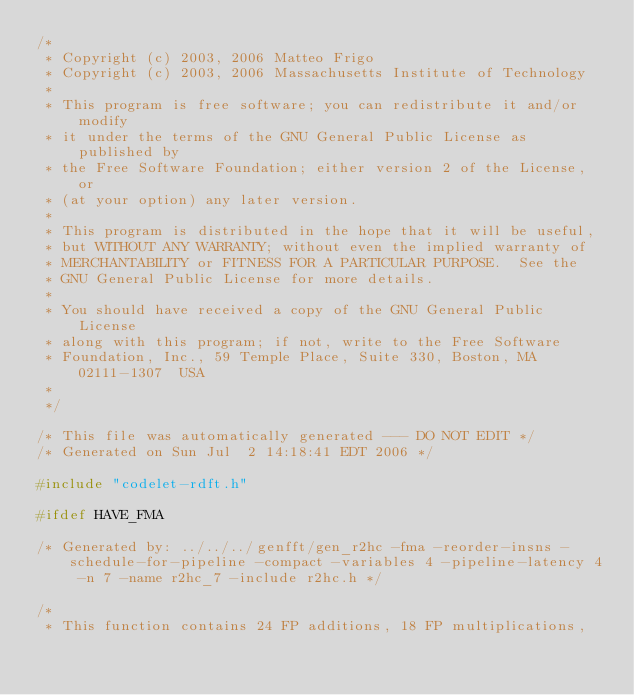Convert code to text. <code><loc_0><loc_0><loc_500><loc_500><_C_>/*
 * Copyright (c) 2003, 2006 Matteo Frigo
 * Copyright (c) 2003, 2006 Massachusetts Institute of Technology
 *
 * This program is free software; you can redistribute it and/or modify
 * it under the terms of the GNU General Public License as published by
 * the Free Software Foundation; either version 2 of the License, or
 * (at your option) any later version.
 *
 * This program is distributed in the hope that it will be useful,
 * but WITHOUT ANY WARRANTY; without even the implied warranty of
 * MERCHANTABILITY or FITNESS FOR A PARTICULAR PURPOSE.  See the
 * GNU General Public License for more details.
 *
 * You should have received a copy of the GNU General Public License
 * along with this program; if not, write to the Free Software
 * Foundation, Inc., 59 Temple Place, Suite 330, Boston, MA  02111-1307  USA
 *
 */

/* This file was automatically generated --- DO NOT EDIT */
/* Generated on Sun Jul  2 14:18:41 EDT 2006 */

#include "codelet-rdft.h"

#ifdef HAVE_FMA

/* Generated by: ../../../genfft/gen_r2hc -fma -reorder-insns -schedule-for-pipeline -compact -variables 4 -pipeline-latency 4 -n 7 -name r2hc_7 -include r2hc.h */

/*
 * This function contains 24 FP additions, 18 FP multiplications,</code> 